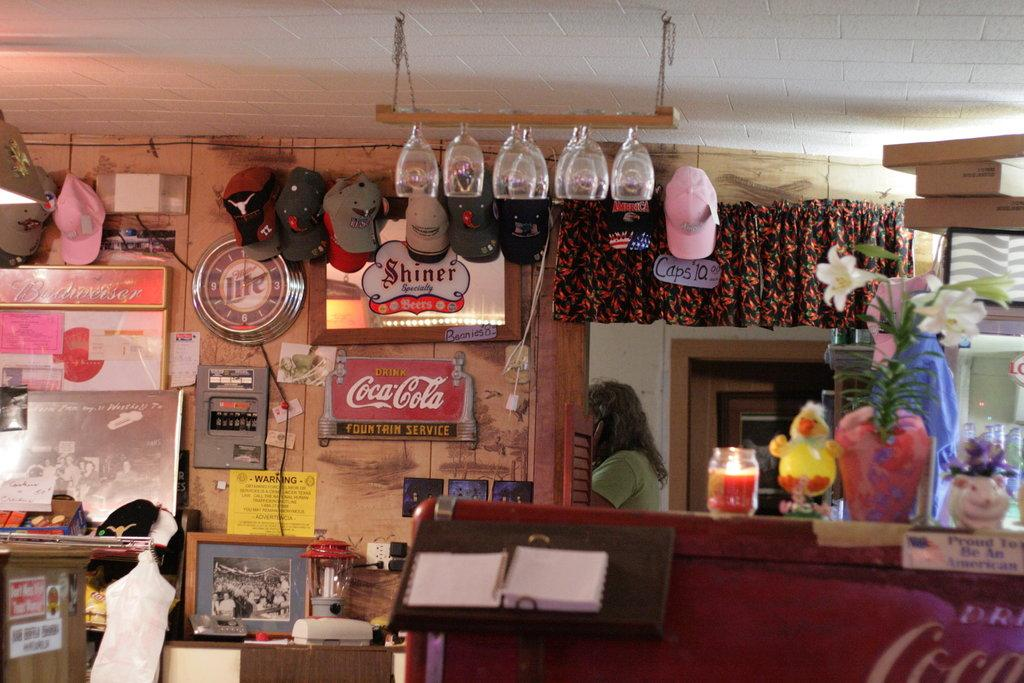<image>
Relay a brief, clear account of the picture shown. A Miller Lite clock is hanging near a Shiner sign. 